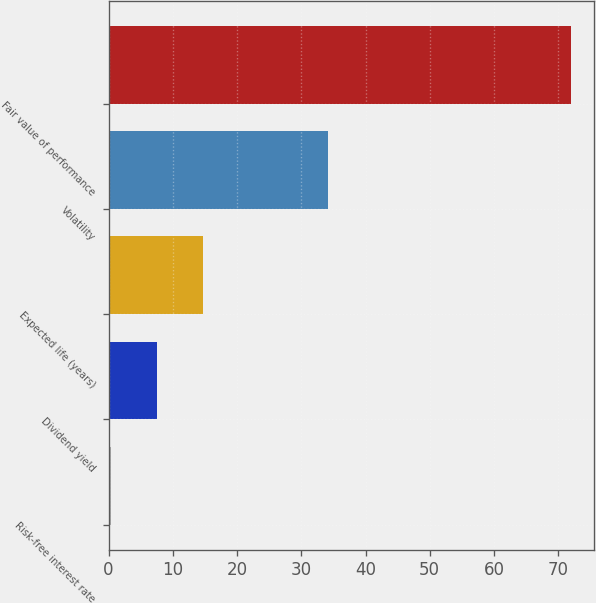Convert chart to OTSL. <chart><loc_0><loc_0><loc_500><loc_500><bar_chart><fcel>Risk-free interest rate<fcel>Dividend yield<fcel>Expected life (years)<fcel>Volatility<fcel>Fair value of performance<nl><fcel>0.37<fcel>7.53<fcel>14.69<fcel>34.1<fcel>71.98<nl></chart> 